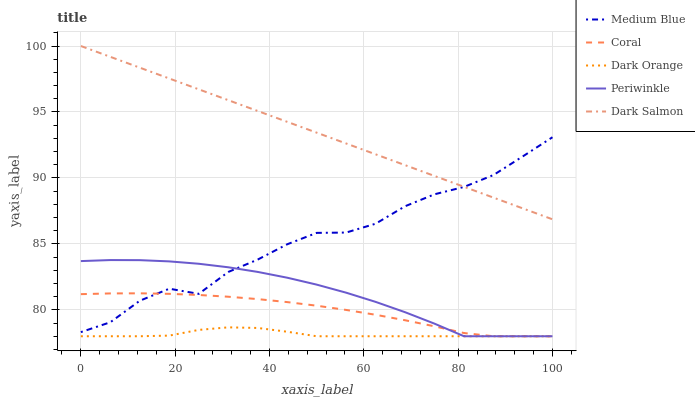Does Dark Orange have the minimum area under the curve?
Answer yes or no. Yes. Does Dark Salmon have the maximum area under the curve?
Answer yes or no. Yes. Does Coral have the minimum area under the curve?
Answer yes or no. No. Does Coral have the maximum area under the curve?
Answer yes or no. No. Is Dark Salmon the smoothest?
Answer yes or no. Yes. Is Medium Blue the roughest?
Answer yes or no. Yes. Is Dark Orange the smoothest?
Answer yes or no. No. Is Dark Orange the roughest?
Answer yes or no. No. Does Periwinkle have the lowest value?
Answer yes or no. Yes. Does Medium Blue have the lowest value?
Answer yes or no. No. Does Dark Salmon have the highest value?
Answer yes or no. Yes. Does Coral have the highest value?
Answer yes or no. No. Is Periwinkle less than Dark Salmon?
Answer yes or no. Yes. Is Medium Blue greater than Dark Orange?
Answer yes or no. Yes. Does Medium Blue intersect Coral?
Answer yes or no. Yes. Is Medium Blue less than Coral?
Answer yes or no. No. Is Medium Blue greater than Coral?
Answer yes or no. No. Does Periwinkle intersect Dark Salmon?
Answer yes or no. No. 